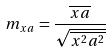<formula> <loc_0><loc_0><loc_500><loc_500>m _ { x a } = \frac { \overline { x a } } { \sqrt { \overline { x ^ { 2 } } \overline { a ^ { 2 } } } }</formula> 